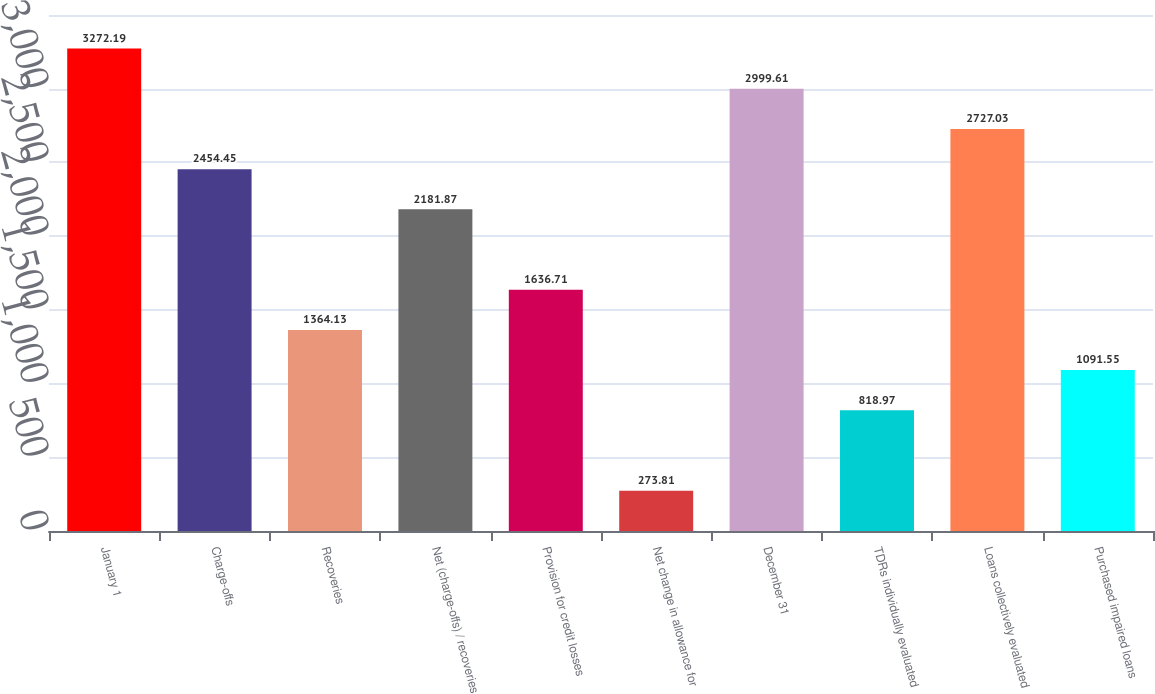Convert chart to OTSL. <chart><loc_0><loc_0><loc_500><loc_500><bar_chart><fcel>January 1<fcel>Charge-offs<fcel>Recoveries<fcel>Net (charge-offs) / recoveries<fcel>Provision for credit losses<fcel>Net change in allowance for<fcel>December 31<fcel>TDRs individually evaluated<fcel>Loans collectively evaluated<fcel>Purchased impaired loans<nl><fcel>3272.19<fcel>2454.45<fcel>1364.13<fcel>2181.87<fcel>1636.71<fcel>273.81<fcel>2999.61<fcel>818.97<fcel>2727.03<fcel>1091.55<nl></chart> 